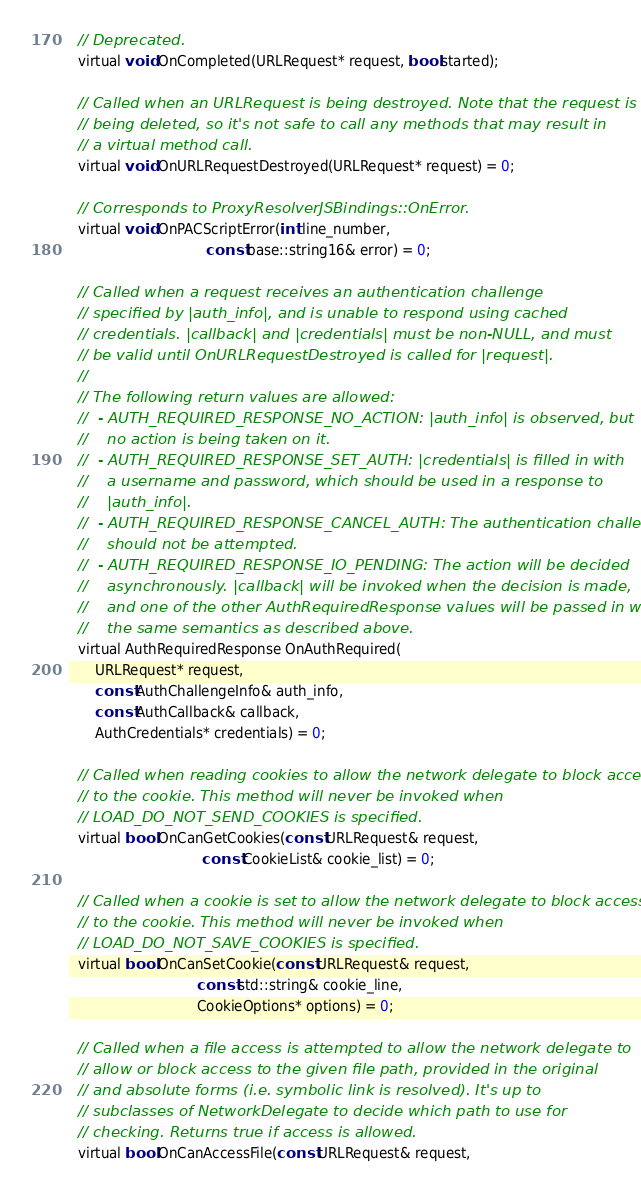Convert code to text. <code><loc_0><loc_0><loc_500><loc_500><_C_>  // Deprecated.
  virtual void OnCompleted(URLRequest* request, bool started);

  // Called when an URLRequest is being destroyed. Note that the request is
  // being deleted, so it's not safe to call any methods that may result in
  // a virtual method call.
  virtual void OnURLRequestDestroyed(URLRequest* request) = 0;

  // Corresponds to ProxyResolverJSBindings::OnError.
  virtual void OnPACScriptError(int line_number,
                                const base::string16& error) = 0;

  // Called when a request receives an authentication challenge
  // specified by |auth_info|, and is unable to respond using cached
  // credentials. |callback| and |credentials| must be non-NULL, and must
  // be valid until OnURLRequestDestroyed is called for |request|.
  //
  // The following return values are allowed:
  //  - AUTH_REQUIRED_RESPONSE_NO_ACTION: |auth_info| is observed, but
  //    no action is being taken on it.
  //  - AUTH_REQUIRED_RESPONSE_SET_AUTH: |credentials| is filled in with
  //    a username and password, which should be used in a response to
  //    |auth_info|.
  //  - AUTH_REQUIRED_RESPONSE_CANCEL_AUTH: The authentication challenge
  //    should not be attempted.
  //  - AUTH_REQUIRED_RESPONSE_IO_PENDING: The action will be decided
  //    asynchronously. |callback| will be invoked when the decision is made,
  //    and one of the other AuthRequiredResponse values will be passed in with
  //    the same semantics as described above.
  virtual AuthRequiredResponse OnAuthRequired(
      URLRequest* request,
      const AuthChallengeInfo& auth_info,
      const AuthCallback& callback,
      AuthCredentials* credentials) = 0;

  // Called when reading cookies to allow the network delegate to block access
  // to the cookie. This method will never be invoked when
  // LOAD_DO_NOT_SEND_COOKIES is specified.
  virtual bool OnCanGetCookies(const URLRequest& request,
                               const CookieList& cookie_list) = 0;

  // Called when a cookie is set to allow the network delegate to block access
  // to the cookie. This method will never be invoked when
  // LOAD_DO_NOT_SAVE_COOKIES is specified.
  virtual bool OnCanSetCookie(const URLRequest& request,
                              const std::string& cookie_line,
                              CookieOptions* options) = 0;

  // Called when a file access is attempted to allow the network delegate to
  // allow or block access to the given file path, provided in the original
  // and absolute forms (i.e. symbolic link is resolved). It's up to
  // subclasses of NetworkDelegate to decide which path to use for
  // checking. Returns true if access is allowed.
  virtual bool OnCanAccessFile(const URLRequest& request,</code> 